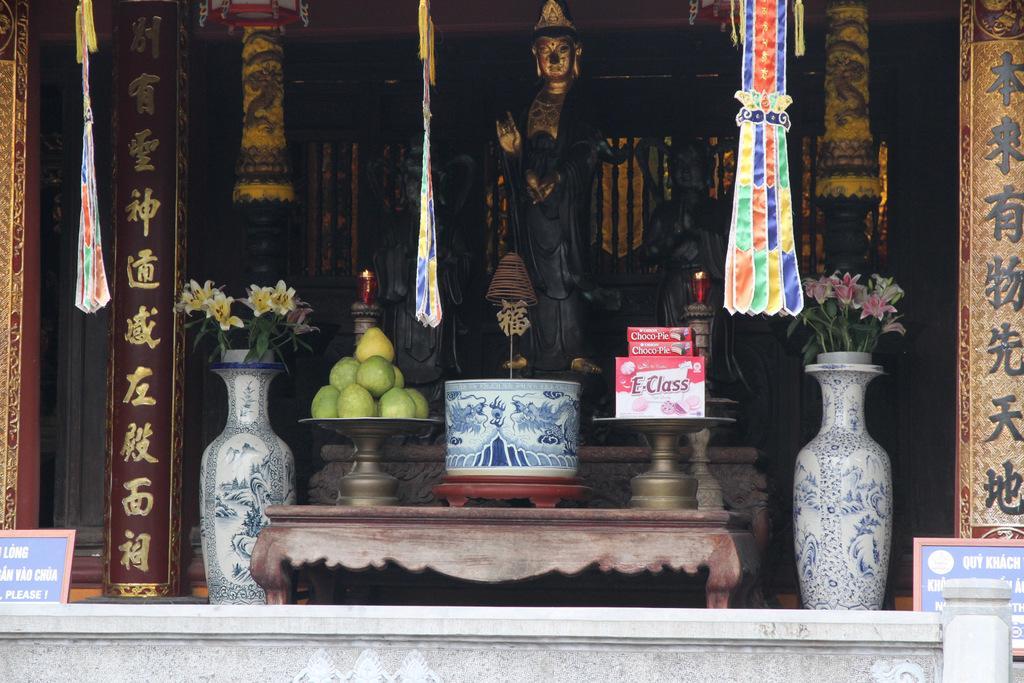How would you summarize this image in a sentence or two? At the center of the image there is a statue, in front of the statue there are some objects and flower pots on the both sides of the statue. In the background there is a wall. 